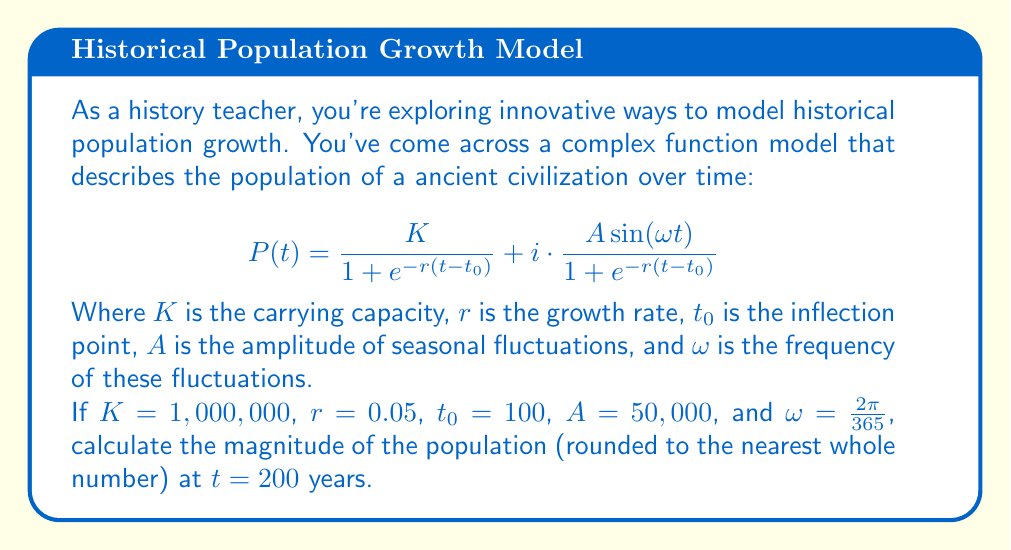Can you solve this math problem? To solve this problem, we'll follow these steps:

1) First, let's break down the complex function into its real and imaginary parts:

   Real part: $$\text{Re}(P(t)) = \frac{K}{1 + e^{-r(t-t_0)}}$$
   
   Imaginary part: $$\text{Im}(P(t)) = \frac{A\sin(\omega t)}{1 + e^{-r(t-t_0)}}$$

2) We'll calculate each part separately for $t = 200$:

   For the real part:
   $$\text{Re}(P(200)) = \frac{1,000,000}{1 + e^{-0.05(200-100)}}$$
   $$= \frac{1,000,000}{1 + e^{-5}} \approx 993,307.15$$

   For the imaginary part:
   $$\text{Im}(P(200)) = \frac{50,000 \sin(\frac{2\pi}{365} \cdot 200)}{1 + e^{-0.05(200-100)}}$$
   $$\approx \frac{50,000 \sin(3.45)}{1 + e^{-5}} \approx -6,632.86$$

3) Now, we have a complex number in the form $a + bi$ where:
   $a \approx 993,307.15$ and $b \approx -6,632.86$

4) To find the magnitude of this complex number, we use the formula:
   $$|P(200)| = \sqrt{a^2 + b^2}$$

5) Plugging in our values:
   $$|P(200)| = \sqrt{993,307.15^2 + (-6,632.86)^2}$$
   $$\approx \sqrt{986,658,891,751.32 + 43,994,839.22}$$
   $$\approx \sqrt{986,702,886,590.54}$$
   $$\approx 993,329.76$$

6) Rounding to the nearest whole number:
   $$|P(200)| \approx 993,330$$

This result represents the total population magnitude, including both the base population (real part) and the seasonal fluctuation (imaginary part).
Answer: 993,330 